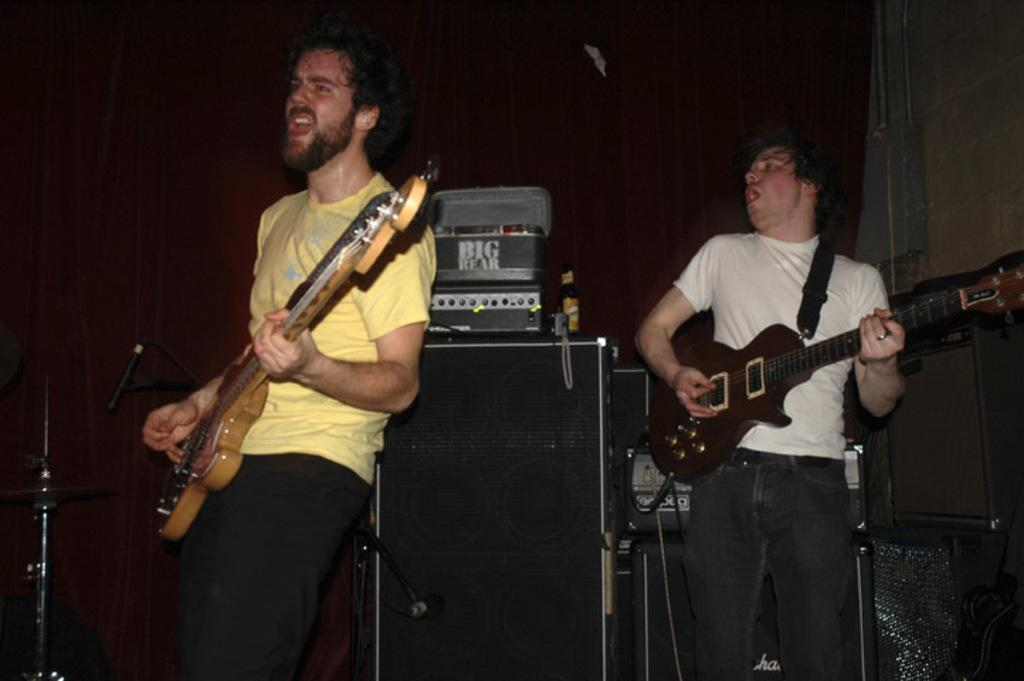How many people are in the image? There are two persons in the image. What are the two persons doing? One person is playing a guitar, and the other person is singing. What is present between the two persons? There is a speaker between the two persons. What can be seen above the speaker? There are boxes and bottles above the speaker. What type of operation is being performed on the guitar in the image? There is no operation being performed on the guitar in the image; it is being played by one of the persons. Can you explain the theory behind the singing technique used by the person in the image? There is no information about the singing technique used by the person in the image, so it is not possible to explain the theory behind it. 